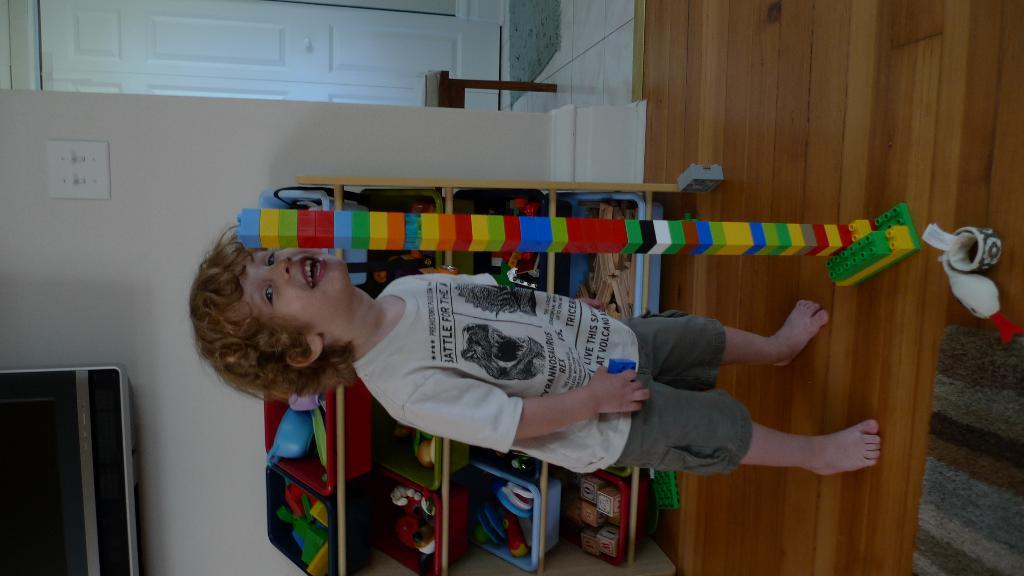Who is the main subject in the image? There is a small boy in the image. What is located behind the boy? There is a rack behind the boy. What electronic device is present in the image? There is a television in the image. Can you identify any entry or exit points in the image? There is a door in the image. What piece of furniture is present in the image? There is a stool in the image. What type of brake is attached to the stool in the image? There is no brake present on the stool in the image. How many bags can be seen in the image? There is no bag present in the image. 